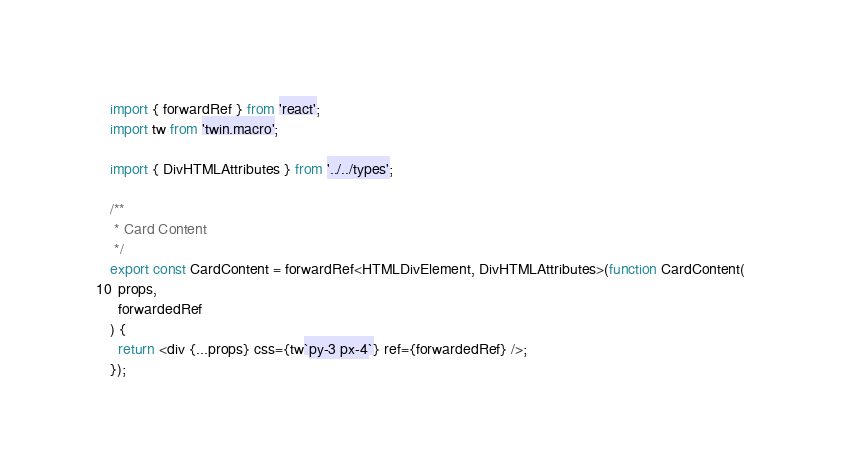<code> <loc_0><loc_0><loc_500><loc_500><_TypeScript_>import { forwardRef } from 'react';
import tw from 'twin.macro';

import { DivHTMLAttributes } from '../../types';

/**
 * Card Content
 */
export const CardContent = forwardRef<HTMLDivElement, DivHTMLAttributes>(function CardContent(
  props,
  forwardedRef
) {
  return <div {...props} css={tw`py-3 px-4`} ref={forwardedRef} />;
});
</code> 